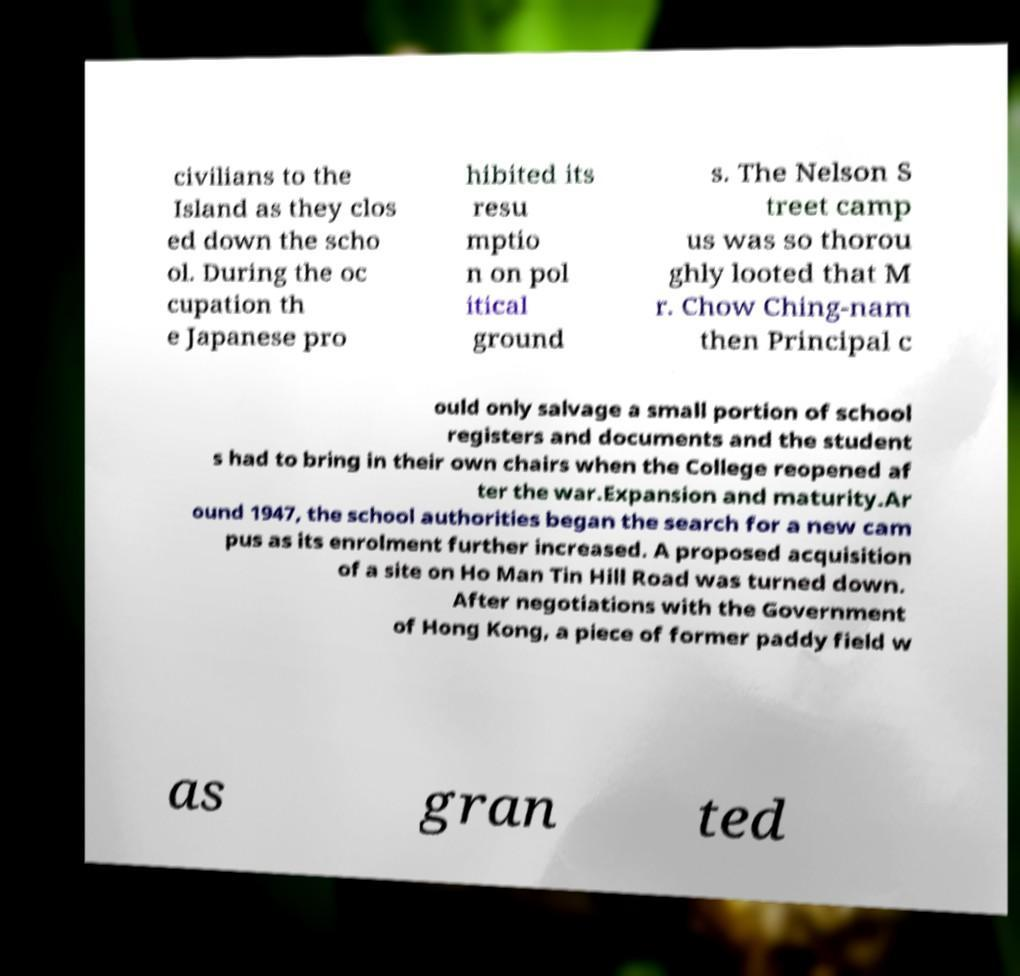What messages or text are displayed in this image? I need them in a readable, typed format. civilians to the Island as they clos ed down the scho ol. During the oc cupation th e Japanese pro hibited its resu mptio n on pol itical ground s. The Nelson S treet camp us was so thorou ghly looted that M r. Chow Ching-nam then Principal c ould only salvage a small portion of school registers and documents and the student s had to bring in their own chairs when the College reopened af ter the war.Expansion and maturity.Ar ound 1947, the school authorities began the search for a new cam pus as its enrolment further increased. A proposed acquisition of a site on Ho Man Tin Hill Road was turned down. After negotiations with the Government of Hong Kong, a piece of former paddy field w as gran ted 